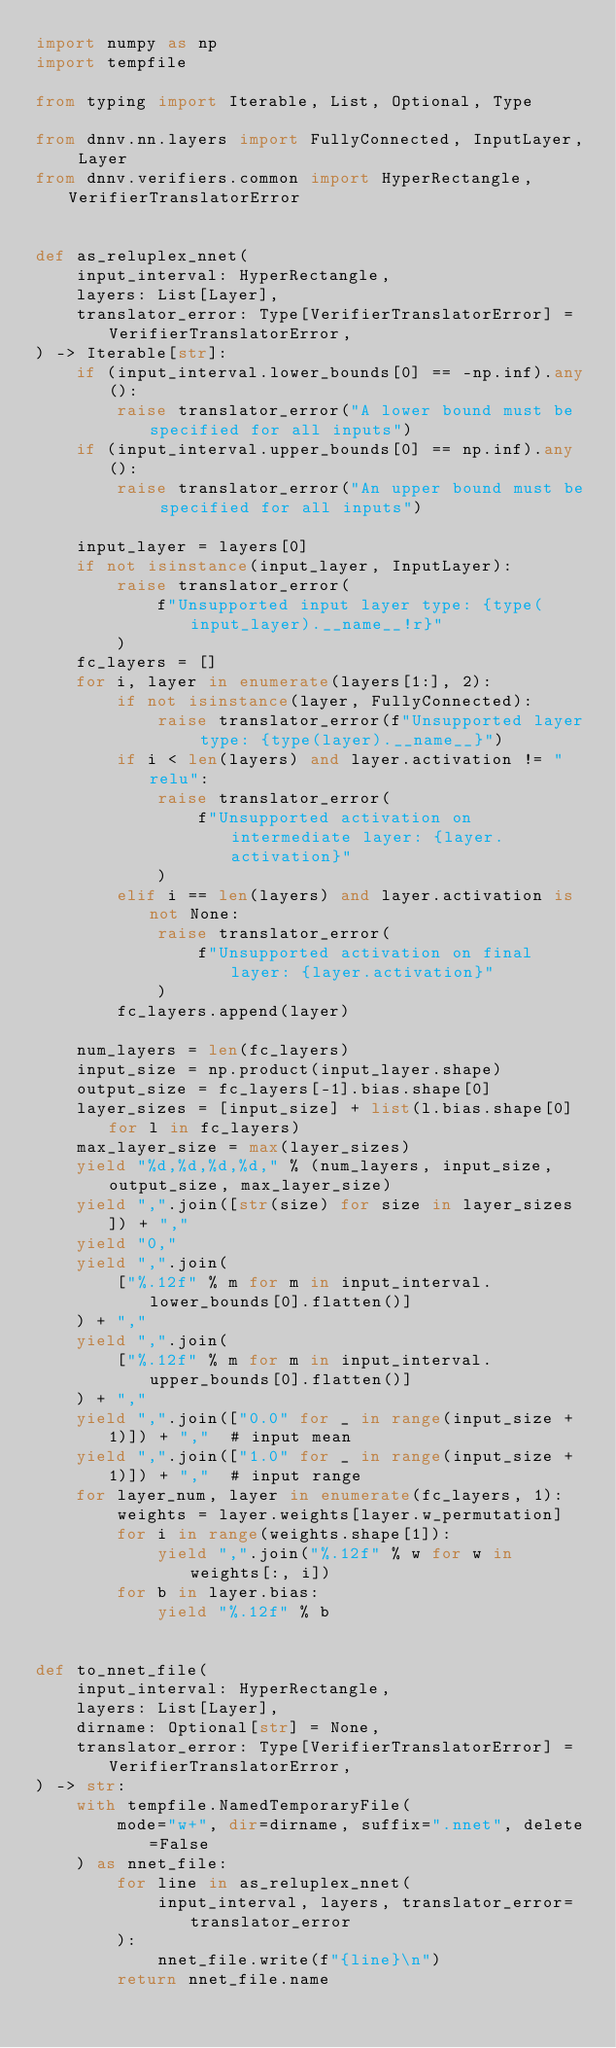Convert code to text. <code><loc_0><loc_0><loc_500><loc_500><_Python_>import numpy as np
import tempfile

from typing import Iterable, List, Optional, Type

from dnnv.nn.layers import FullyConnected, InputLayer, Layer
from dnnv.verifiers.common import HyperRectangle, VerifierTranslatorError


def as_reluplex_nnet(
    input_interval: HyperRectangle,
    layers: List[Layer],
    translator_error: Type[VerifierTranslatorError] = VerifierTranslatorError,
) -> Iterable[str]:
    if (input_interval.lower_bounds[0] == -np.inf).any():
        raise translator_error("A lower bound must be specified for all inputs")
    if (input_interval.upper_bounds[0] == np.inf).any():
        raise translator_error("An upper bound must be specified for all inputs")

    input_layer = layers[0]
    if not isinstance(input_layer, InputLayer):
        raise translator_error(
            f"Unsupported input layer type: {type(input_layer).__name__!r}"
        )
    fc_layers = []
    for i, layer in enumerate(layers[1:], 2):
        if not isinstance(layer, FullyConnected):
            raise translator_error(f"Unsupported layer type: {type(layer).__name__}")
        if i < len(layers) and layer.activation != "relu":
            raise translator_error(
                f"Unsupported activation on intermediate layer: {layer.activation}"
            )
        elif i == len(layers) and layer.activation is not None:
            raise translator_error(
                f"Unsupported activation on final layer: {layer.activation}"
            )
        fc_layers.append(layer)

    num_layers = len(fc_layers)
    input_size = np.product(input_layer.shape)
    output_size = fc_layers[-1].bias.shape[0]
    layer_sizes = [input_size] + list(l.bias.shape[0] for l in fc_layers)
    max_layer_size = max(layer_sizes)
    yield "%d,%d,%d,%d," % (num_layers, input_size, output_size, max_layer_size)
    yield ",".join([str(size) for size in layer_sizes]) + ","
    yield "0,"
    yield ",".join(
        ["%.12f" % m for m in input_interval.lower_bounds[0].flatten()]
    ) + ","
    yield ",".join(
        ["%.12f" % m for m in input_interval.upper_bounds[0].flatten()]
    ) + ","
    yield ",".join(["0.0" for _ in range(input_size + 1)]) + ","  # input mean
    yield ",".join(["1.0" for _ in range(input_size + 1)]) + ","  # input range
    for layer_num, layer in enumerate(fc_layers, 1):
        weights = layer.weights[layer.w_permutation]
        for i in range(weights.shape[1]):
            yield ",".join("%.12f" % w for w in weights[:, i])
        for b in layer.bias:
            yield "%.12f" % b


def to_nnet_file(
    input_interval: HyperRectangle,
    layers: List[Layer],
    dirname: Optional[str] = None,
    translator_error: Type[VerifierTranslatorError] = VerifierTranslatorError,
) -> str:
    with tempfile.NamedTemporaryFile(
        mode="w+", dir=dirname, suffix=".nnet", delete=False
    ) as nnet_file:
        for line in as_reluplex_nnet(
            input_interval, layers, translator_error=translator_error
        ):
            nnet_file.write(f"{line}\n")
        return nnet_file.name
</code> 